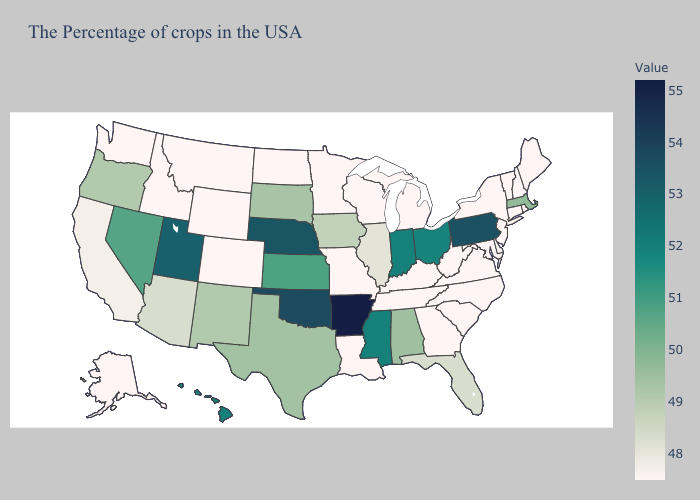Does Nebraska have the lowest value in the USA?
Concise answer only. No. Does Missouri have the lowest value in the MidWest?
Quick response, please. Yes. Does Massachusetts have the lowest value in the USA?
Answer briefly. No. Does Massachusetts have the lowest value in the Northeast?
Keep it brief. No. Does Oregon have a lower value than Minnesota?
Short answer required. No. Which states have the lowest value in the USA?
Be succinct. Maine, Rhode Island, New Hampshire, Vermont, Connecticut, New York, New Jersey, Delaware, Maryland, Virginia, North Carolina, South Carolina, West Virginia, Georgia, Michigan, Kentucky, Tennessee, Wisconsin, Louisiana, Missouri, Minnesota, North Dakota, Wyoming, Colorado, Montana, Idaho, Washington, Alaska. Among the states that border Nevada , does Utah have the highest value?
Quick response, please. Yes. 